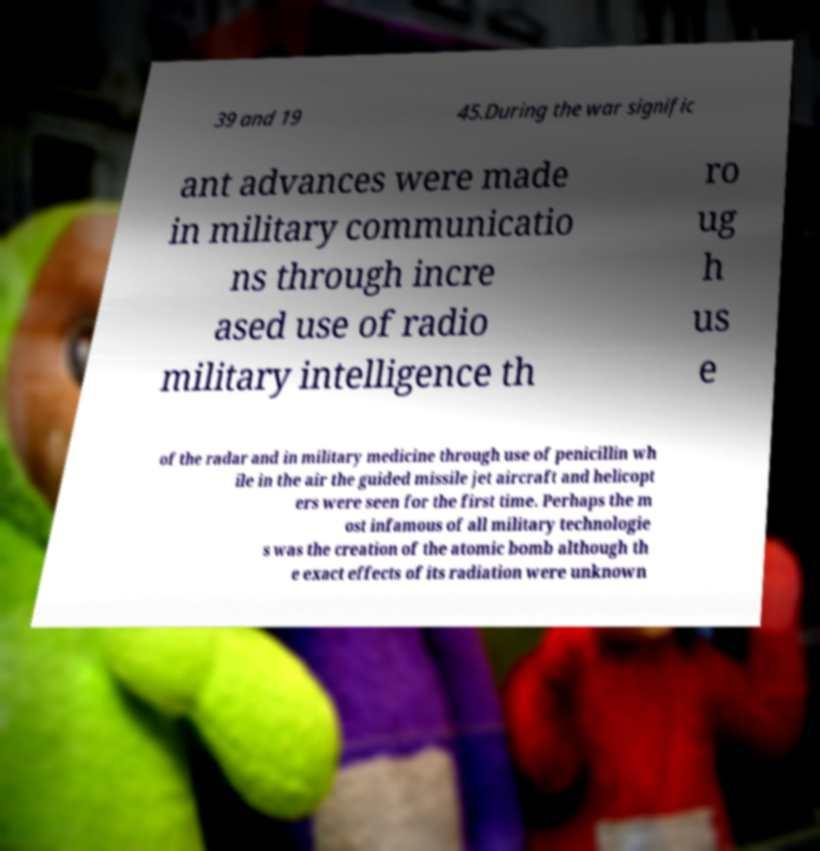For documentation purposes, I need the text within this image transcribed. Could you provide that? 39 and 19 45.During the war signific ant advances were made in military communicatio ns through incre ased use of radio military intelligence th ro ug h us e of the radar and in military medicine through use of penicillin wh ile in the air the guided missile jet aircraft and helicopt ers were seen for the first time. Perhaps the m ost infamous of all military technologie s was the creation of the atomic bomb although th e exact effects of its radiation were unknown 